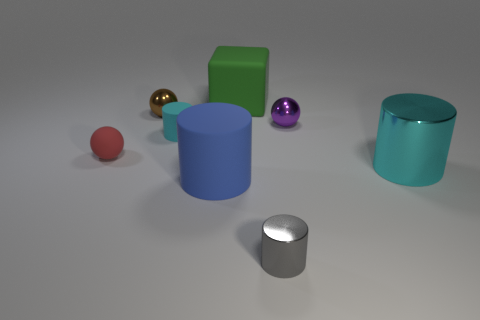Subtract 1 cylinders. How many cylinders are left? 3 Add 1 cyan rubber things. How many objects exist? 9 Subtract all spheres. How many objects are left? 5 Subtract 0 cyan blocks. How many objects are left? 8 Subtract all small spheres. Subtract all large brown rubber balls. How many objects are left? 5 Add 6 small matte cylinders. How many small matte cylinders are left? 7 Add 5 big red spheres. How many big red spheres exist? 5 